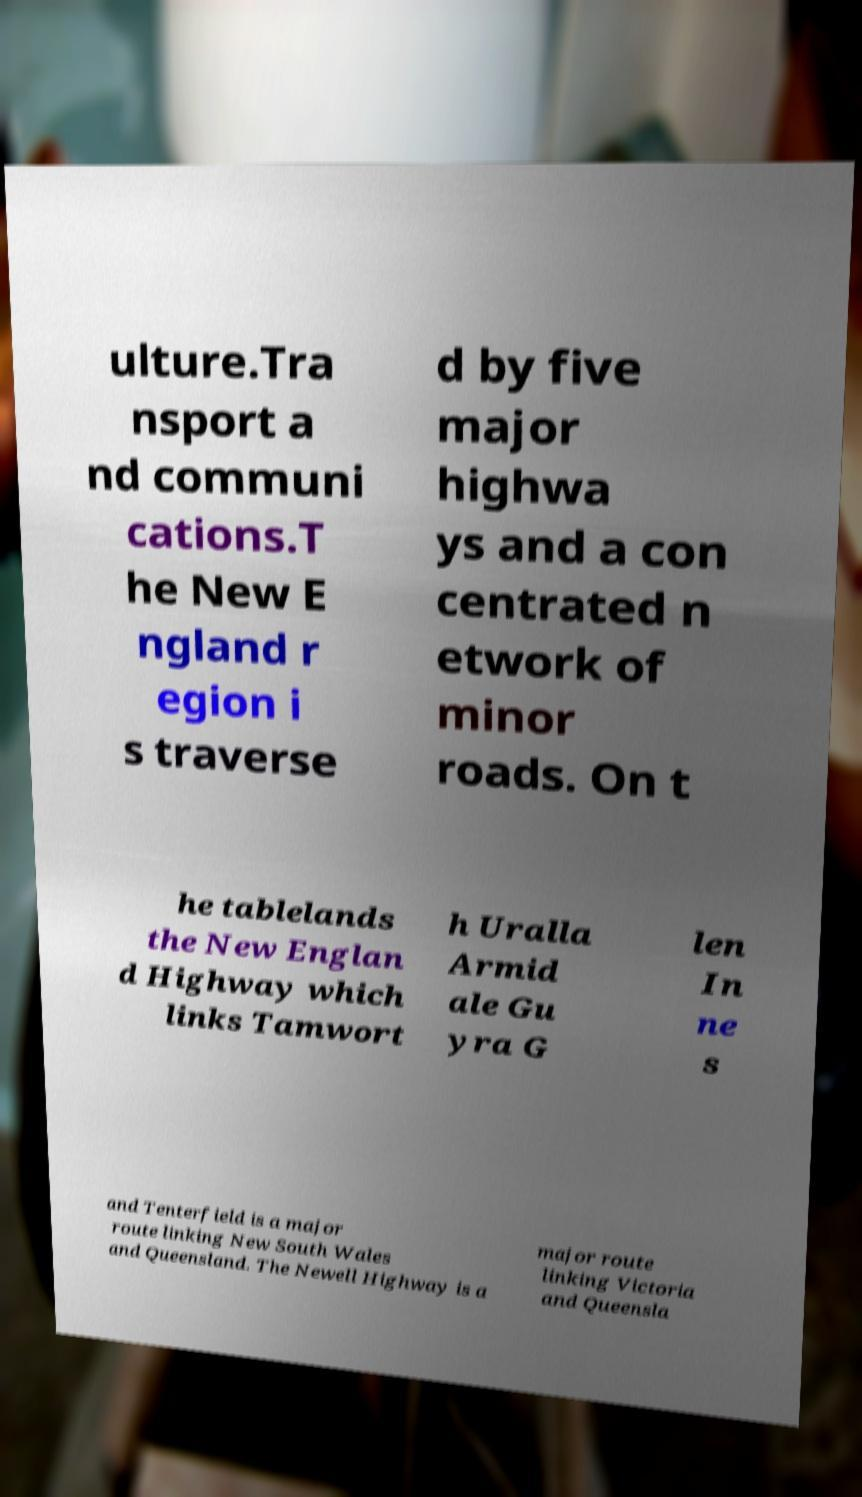I need the written content from this picture converted into text. Can you do that? ulture.Tra nsport a nd communi cations.T he New E ngland r egion i s traverse d by five major highwa ys and a con centrated n etwork of minor roads. On t he tablelands the New Englan d Highway which links Tamwort h Uralla Armid ale Gu yra G len In ne s and Tenterfield is a major route linking New South Wales and Queensland. The Newell Highway is a major route linking Victoria and Queensla 